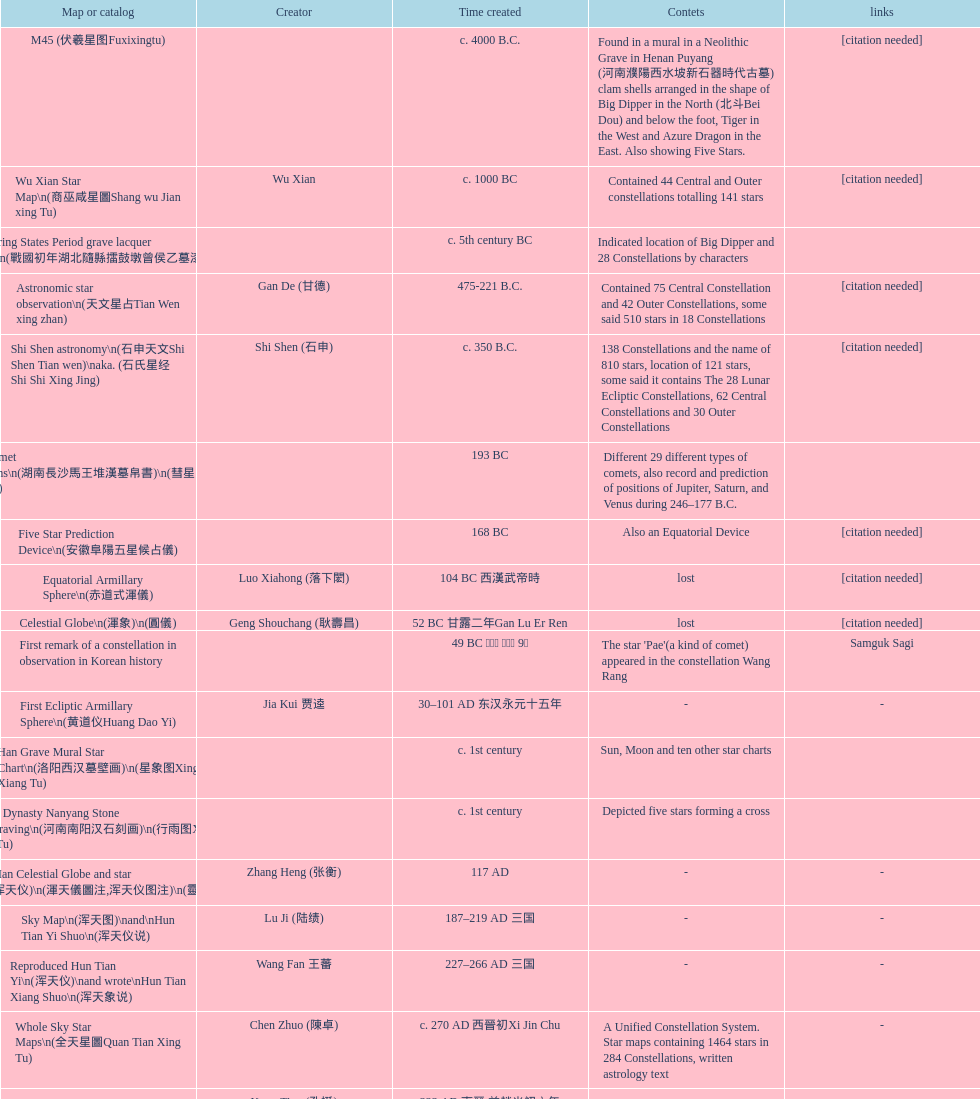Which map or catalog was created last? Sky in Google Earth KML. 